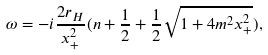Convert formula to latex. <formula><loc_0><loc_0><loc_500><loc_500>\omega = - i \frac { 2 r _ { H } } { x _ { + } ^ { 2 } } ( n + \frac { 1 } { 2 } + \frac { 1 } { 2 } \sqrt { 1 + 4 m ^ { 2 } x _ { + } ^ { 2 } } ) ,</formula> 